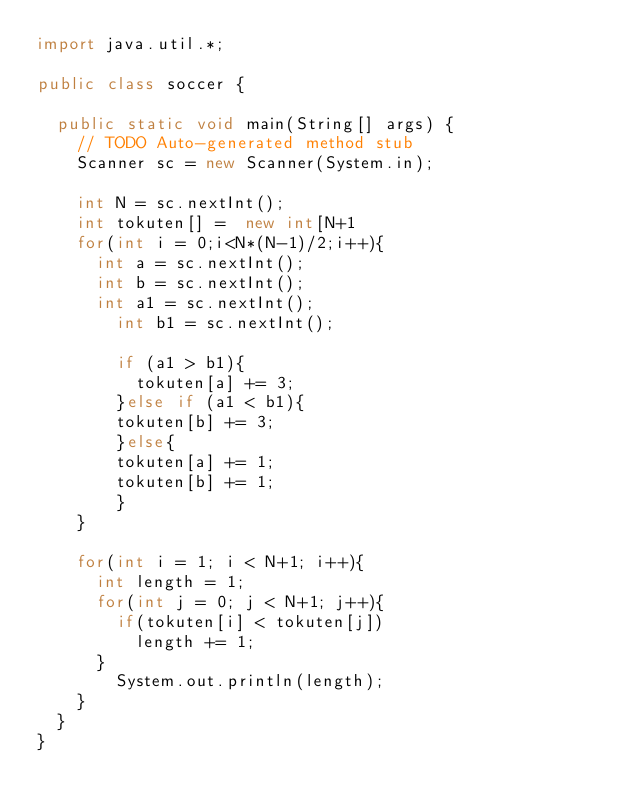<code> <loc_0><loc_0><loc_500><loc_500><_Java_>import java.util.*;

public class soccer {

	public static void main(String[] args) {
		// TODO Auto-generated method stub
		Scanner sc = new Scanner(System.in);
		
		int N = sc.nextInt();
		int tokuten[] =  new int[N+1
		for(int i = 0;i<N*(N-1)/2;i++){
			int a = sc.nextInt();
			int b = sc.nextInt();
			int a1 = sc.nextInt();
		    int b1 = sc.nextInt();
		    
		    if (a1 > b1){
		    	tokuten[a] += 3;
		    }else if (a1 < b1){
		    tokuten[b] += 3;
		    }else{
		    tokuten[a] += 1;
		    tokuten[b] += 1;
		    }
		}

		for(int i = 1; i < N+1; i++){
			int length = 1;
			for(int j = 0; j < N+1; j++){
				if(tokuten[i] < tokuten[j])
					length += 1;
			}
		    System.out.println(length);
		}
	}
}</code> 